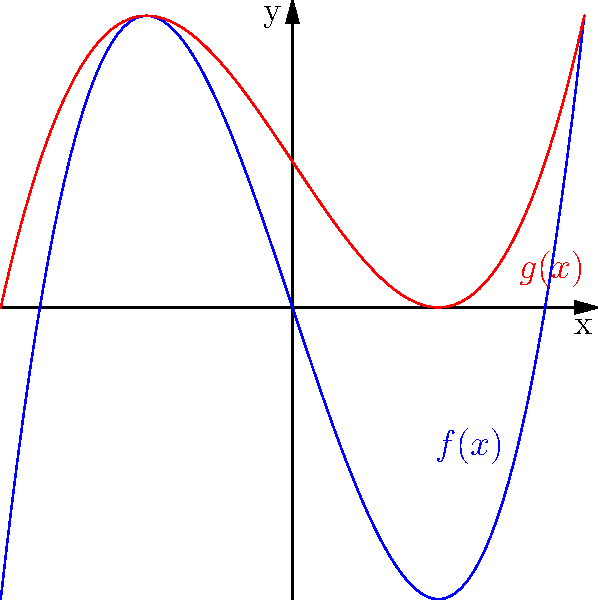Consider the polynomials $f(x) = x^3 - 3x$ and $g(x) = 0.5(x^3 - 3x) + 1$, which represent simplified forms of curves found in traditional Persian architecture. How does $g(x)$ relate to $f(x)$ in terms of transformations? Describe the vertical stretch/compression and vertical shift. To understand how $g(x)$ relates to $f(x)$, let's analyze the transformations step-by-step:

1. Start with $f(x) = x^3 - 3x$

2. To get $g(x)$, we first apply a vertical stretch/compression:
   $0.5(x^3 - 3x)$
   This multiplies the function by 0.5, which compresses it vertically by a factor of 2.

3. Then, we apply a vertical shift:
   $0.5(x^3 - 3x) + 1$
   This shifts the compressed function up by 1 unit.

4. Therefore, $g(x)$ is obtained from $f(x)$ by:
   a) Compressing vertically by a factor of 2 (multiply by 0.5)
   b) Shifting up by 1 unit

5. In the graph, we can see that the red curve ($g(x)$) is a vertically compressed and upward-shifted version of the blue curve ($f(x)$).

This transformation mirrors the way traditional Persian architectural elements often incorporate scaled and shifted versions of basic geometric shapes to create complex and harmonious designs.
Answer: Vertical compression by factor 2, then vertical shift up 1 unit. 